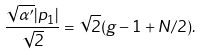Convert formula to latex. <formula><loc_0><loc_0><loc_500><loc_500>\frac { \sqrt { \alpha ^ { \prime } } | p _ { 1 } | } { \sqrt { 2 } } = \sqrt { 2 } ( g - 1 + N / 2 ) .</formula> 